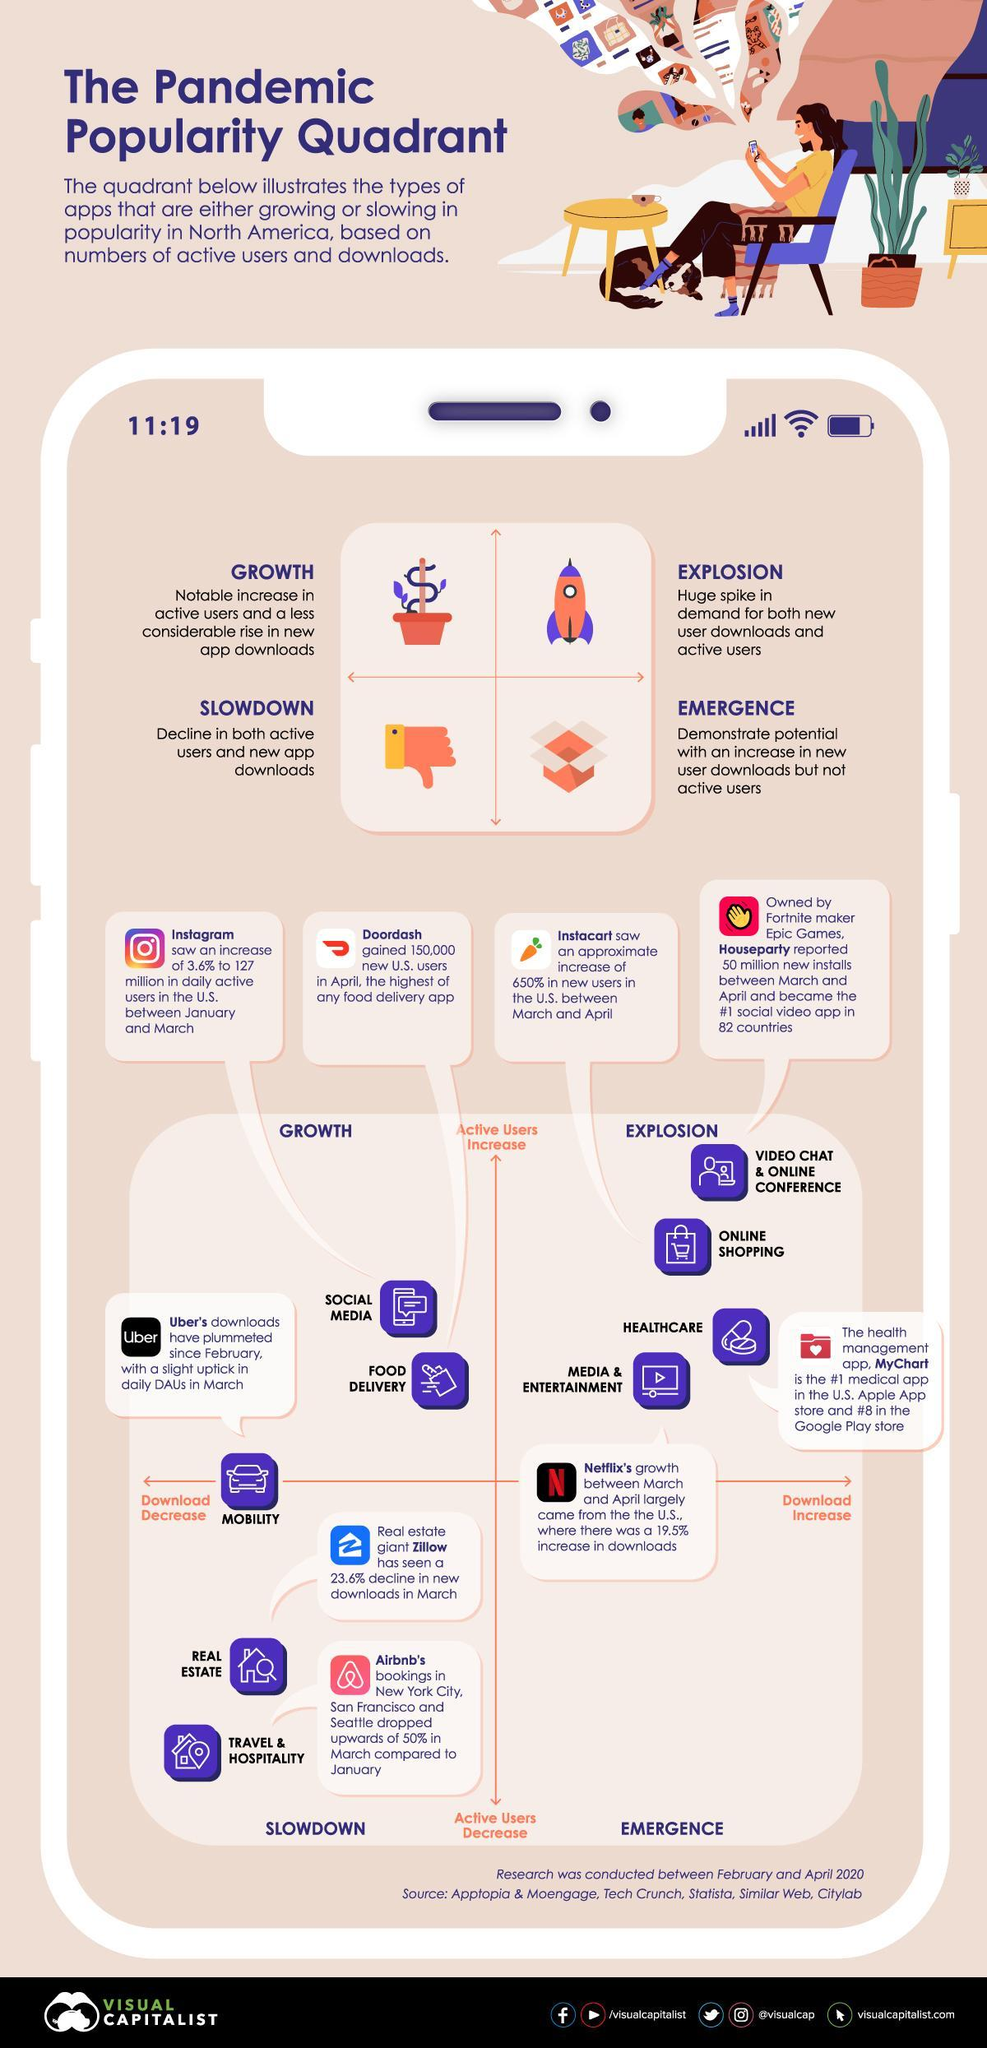which category of app achieved highest growth in number of active users?
Answer the question with a short phrase. video chat and online conference Total number of different categories of apps given in this infographic is? 9 download count of how many categories of apps have been increased? 4 What is top right quadrant is called? explosion What is left bottom quadrant is called? slowdown How many categories of applications are there in emergence quadrant? 0 download count of how many categories of apps have been decreased? 5 Which application category has the highest increase in downloads? healthcare Which are the category of applications that lies within the slowdown quadrant completely? real estate, travel and hospitality What are the category of applications that are in the explosion phase apart from video chat and online conference ? online shopping, healthcare, media and entertainment Which are the category of applications that lies within the growth quadrant completely? social media, food delivery How many categories of applications are there in explosion quadrant? 4 